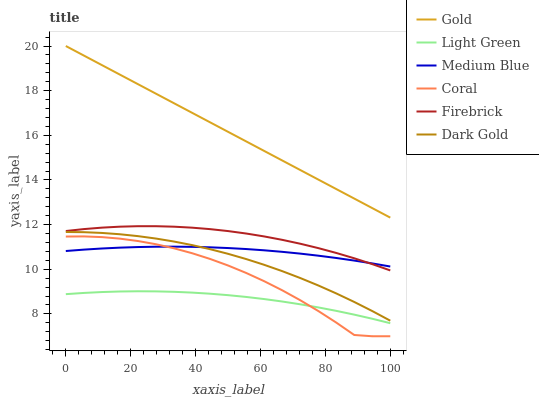Does Dark Gold have the minimum area under the curve?
Answer yes or no. No. Does Dark Gold have the maximum area under the curve?
Answer yes or no. No. Is Dark Gold the smoothest?
Answer yes or no. No. Is Dark Gold the roughest?
Answer yes or no. No. Does Dark Gold have the lowest value?
Answer yes or no. No. Does Dark Gold have the highest value?
Answer yes or no. No. Is Firebrick less than Gold?
Answer yes or no. Yes. Is Gold greater than Light Green?
Answer yes or no. Yes. Does Firebrick intersect Gold?
Answer yes or no. No. 